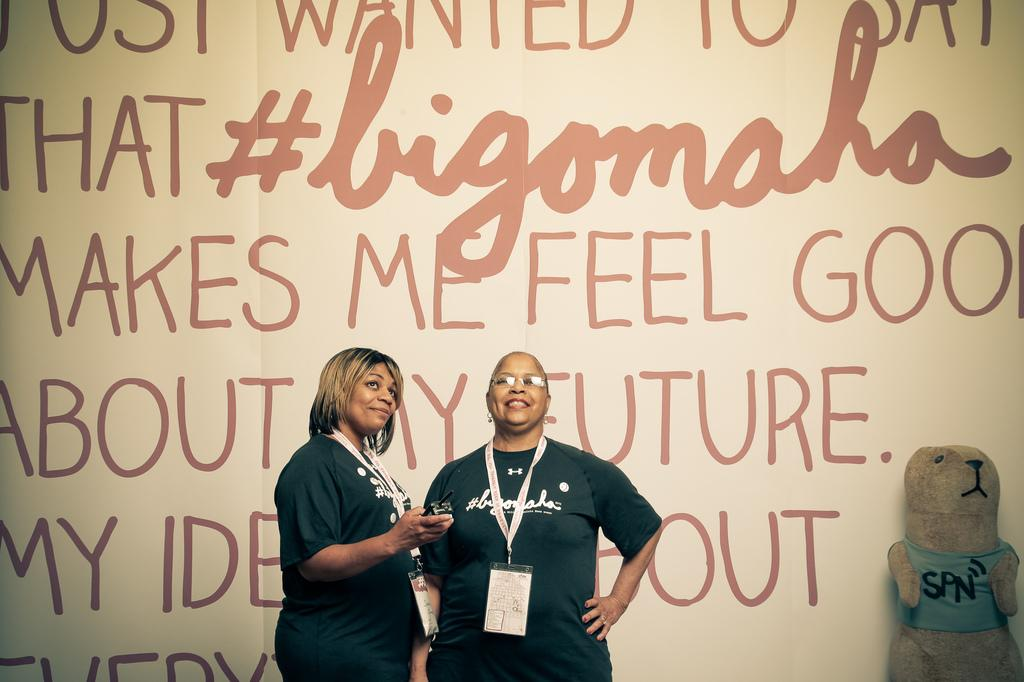How many people are in the image? There are two people in the image. What is the facial expression of the people in the image? The people are smiling. What are the people wearing that might identify them? The people are wearing ID cards. What object can be seen in the image that is typically associated with comfort and childhood? There is a teddy bear in the image. What can be seen in the background of the image? There is a poster in the background of the image. Can you see any ghosts interacting with the people in the image? No, there are no ghosts present in the image. What type of tramp is visible in the image? There is no tramp present in the image. 